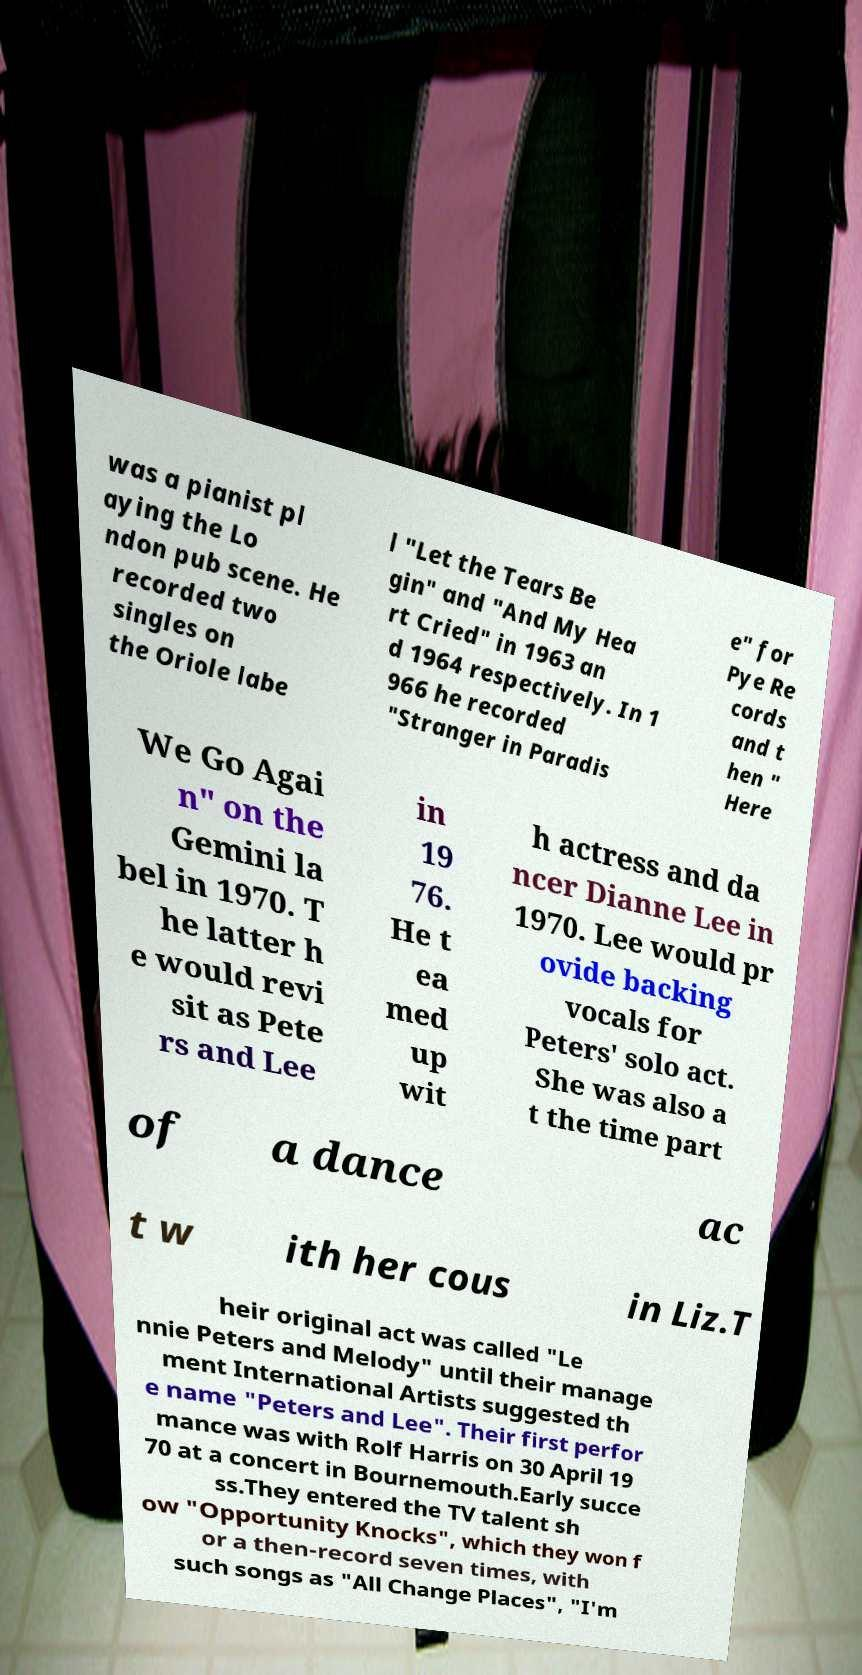Can you accurately transcribe the text from the provided image for me? was a pianist pl aying the Lo ndon pub scene. He recorded two singles on the Oriole labe l "Let the Tears Be gin" and "And My Hea rt Cried" in 1963 an d 1964 respectively. In 1 966 he recorded "Stranger in Paradis e" for Pye Re cords and t hen " Here We Go Agai n" on the Gemini la bel in 1970. T he latter h e would revi sit as Pete rs and Lee in 19 76. He t ea med up wit h actress and da ncer Dianne Lee in 1970. Lee would pr ovide backing vocals for Peters' solo act. She was also a t the time part of a dance ac t w ith her cous in Liz.T heir original act was called "Le nnie Peters and Melody" until their manage ment International Artists suggested th e name "Peters and Lee". Their first perfor mance was with Rolf Harris on 30 April 19 70 at a concert in Bournemouth.Early succe ss.They entered the TV talent sh ow "Opportunity Knocks", which they won f or a then-record seven times, with such songs as "All Change Places", "I'm 